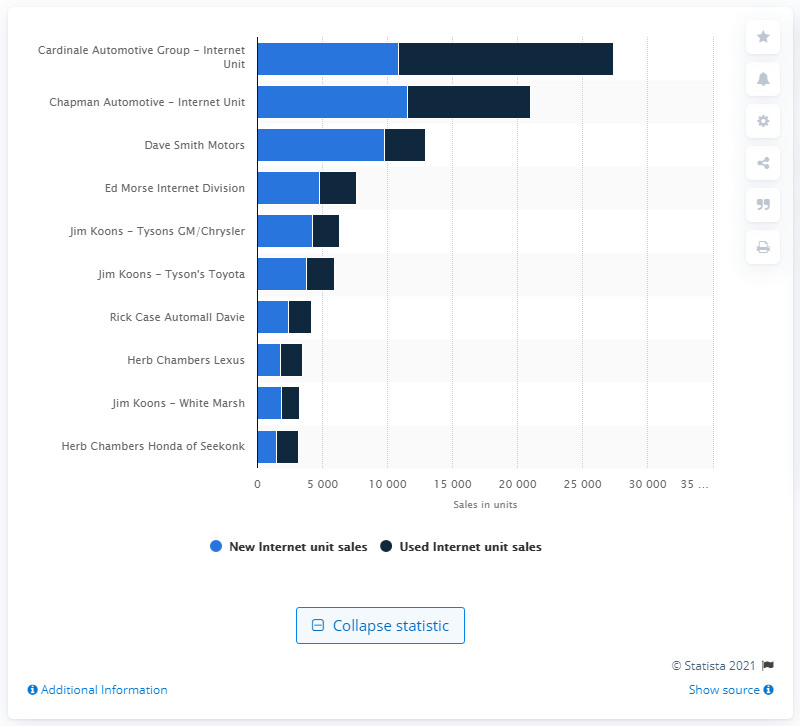Identify some key points in this picture. Dave Smith Motors was the third largest e-dealer between January and December 2018. 